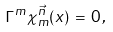Convert formula to latex. <formula><loc_0><loc_0><loc_500><loc_500>\Gamma ^ { m } \chi _ { m } ^ { \vec { n } } ( x ) \, = \, 0 \, ,</formula> 